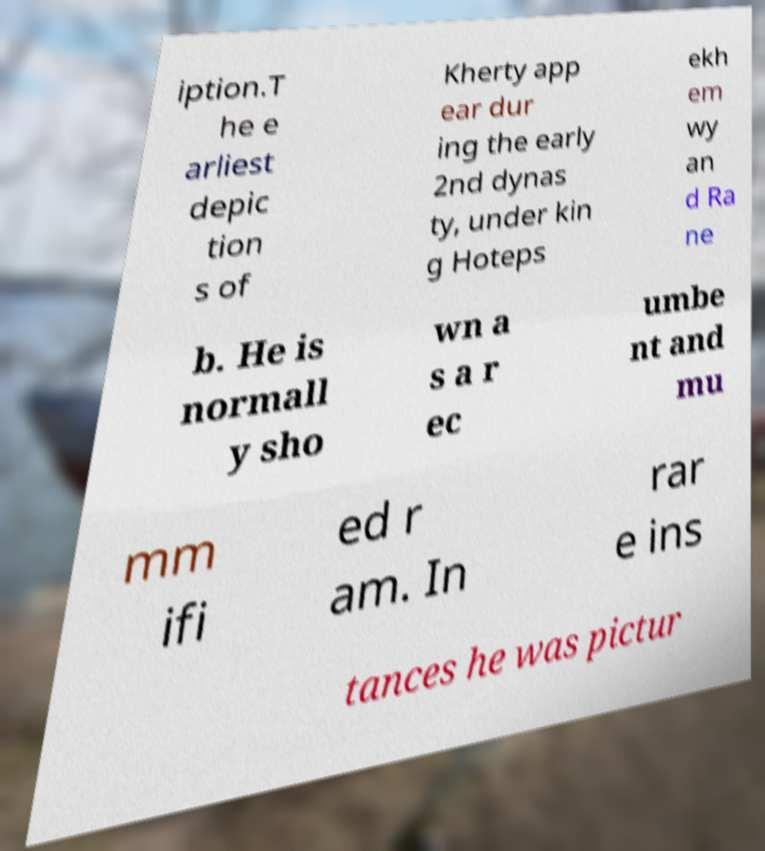For documentation purposes, I need the text within this image transcribed. Could you provide that? iption.T he e arliest depic tion s of Kherty app ear dur ing the early 2nd dynas ty, under kin g Hoteps ekh em wy an d Ra ne b. He is normall y sho wn a s a r ec umbe nt and mu mm ifi ed r am. In rar e ins tances he was pictur 